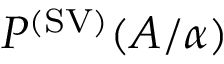Convert formula to latex. <formula><loc_0><loc_0><loc_500><loc_500>P ^ { ( S V ) } ( A / \alpha )</formula> 